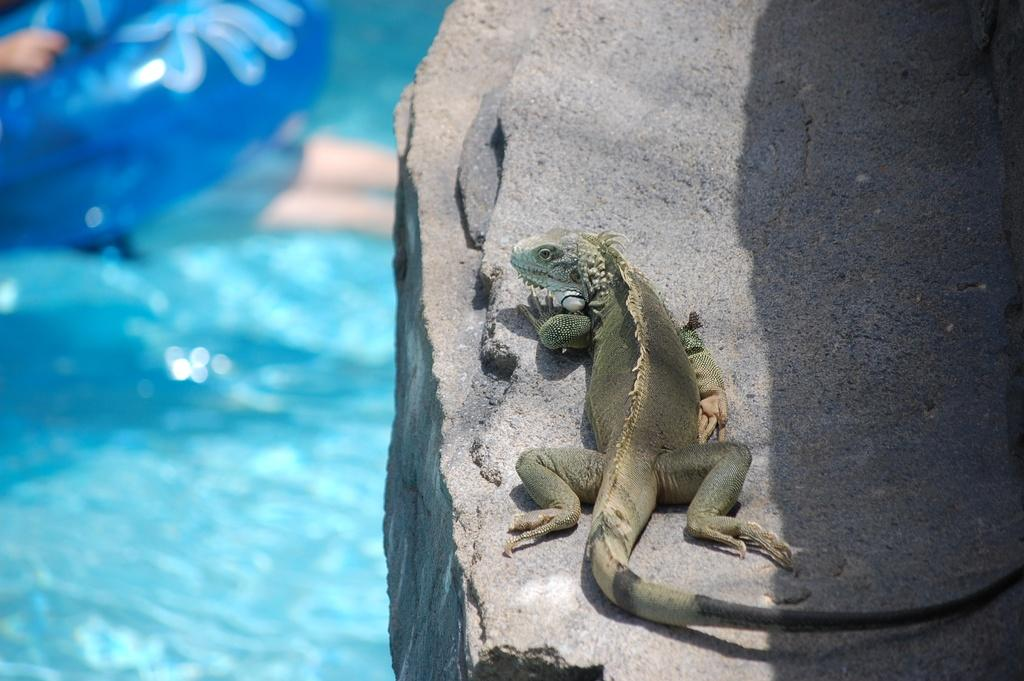What type of animal is in the picture? There is an iguana in the picture. Where is the iguana located? The iguana is on a rock. What can be seen on the left side of the rock? There is water on the left side of the rock, and there are other things visible on the left side of the rock. What is the name of the iguana in the picture? The provided facts do not mention the name of the iguana, so we cannot determine its name from the image. 